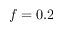Convert formula to latex. <formula><loc_0><loc_0><loc_500><loc_500>f = 0 . 2</formula> 